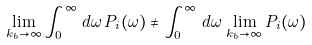Convert formula to latex. <formula><loc_0><loc_0><loc_500><loc_500>\lim _ { k _ { b } \to \infty } \int _ { 0 } ^ { \infty } \, d \omega \, P _ { i } ( \omega ) \ne \int _ { 0 } ^ { \infty } \, d \omega \, \lim _ { k _ { b } \to \infty } P _ { i } ( \omega )</formula> 